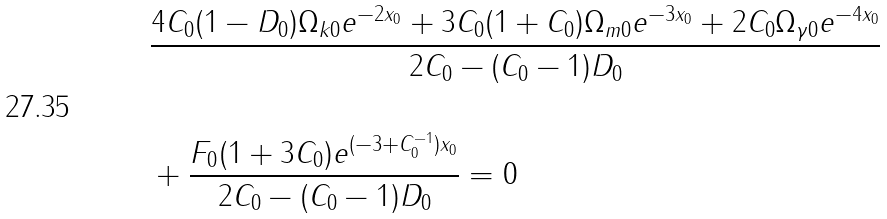Convert formula to latex. <formula><loc_0><loc_0><loc_500><loc_500>& \frac { 4 C _ { 0 } ( 1 - D _ { 0 } ) \Omega _ { k 0 } e ^ { - 2 x _ { 0 } } + 3 C _ { 0 } ( 1 + C _ { 0 } ) \Omega _ { m 0 } e ^ { - 3 x _ { 0 } } + 2 C _ { 0 } \Omega _ { \gamma 0 } e ^ { - 4 x _ { 0 } } } { 2 C _ { 0 } - ( C _ { 0 } - 1 ) D _ { 0 } } \\ & \\ & + \frac { F _ { 0 } ( 1 + 3 C _ { 0 } ) e ^ { ( - 3 + C _ { 0 } ^ { - 1 } ) x _ { 0 } } } { 2 C _ { 0 } - ( C _ { 0 } - 1 ) D _ { 0 } } = 0 \\</formula> 